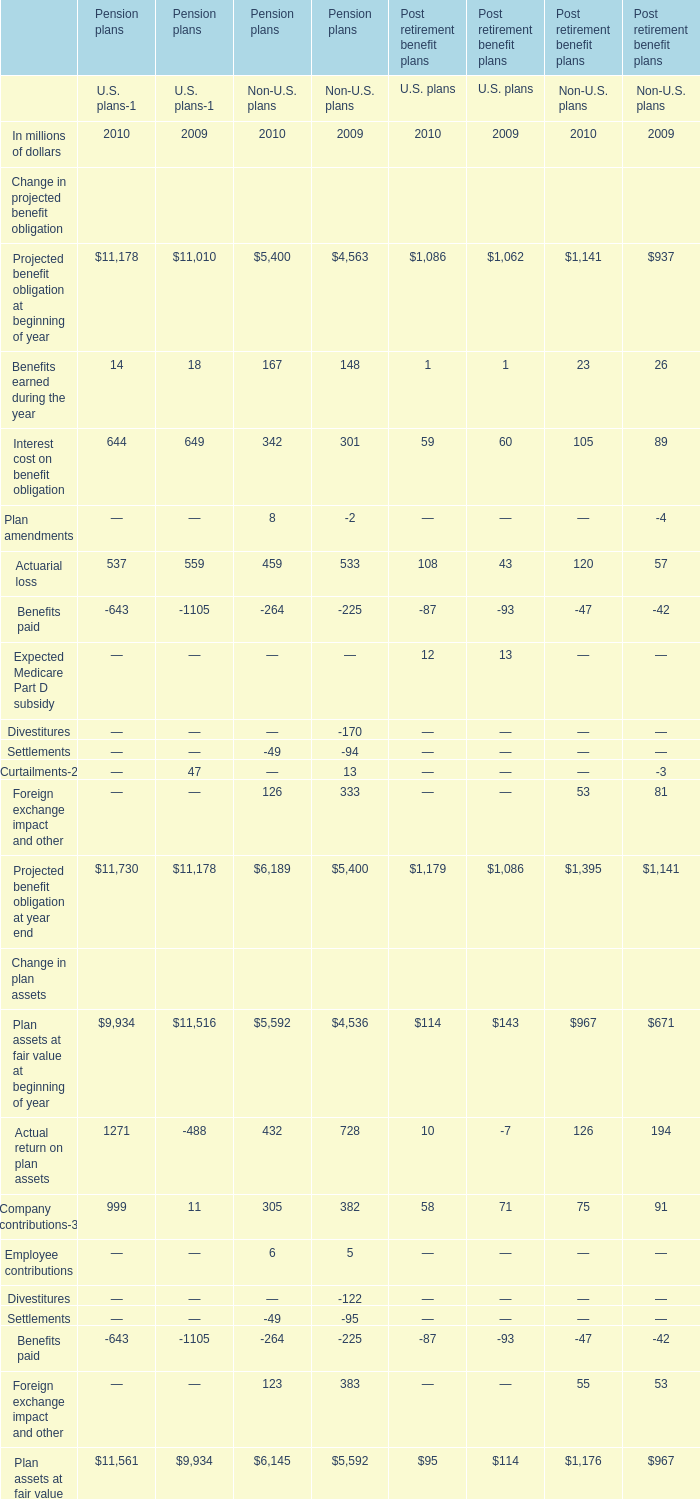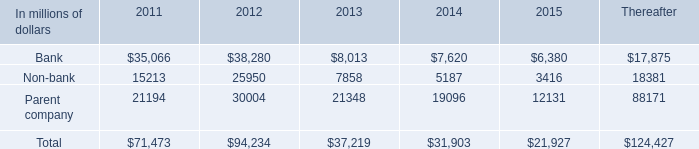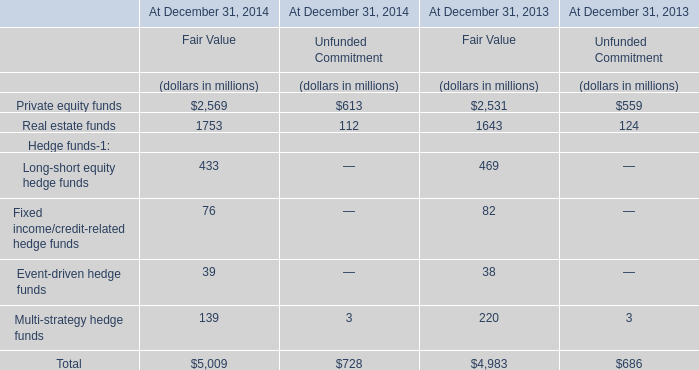What is the proportion of all Benefits earned during the year that are greater than 100 to the total amount of Benefits earned during the year, in 2010? 
Computations: (167 / (((14 + 167) + 1) + 23))
Answer: 0.81463. 